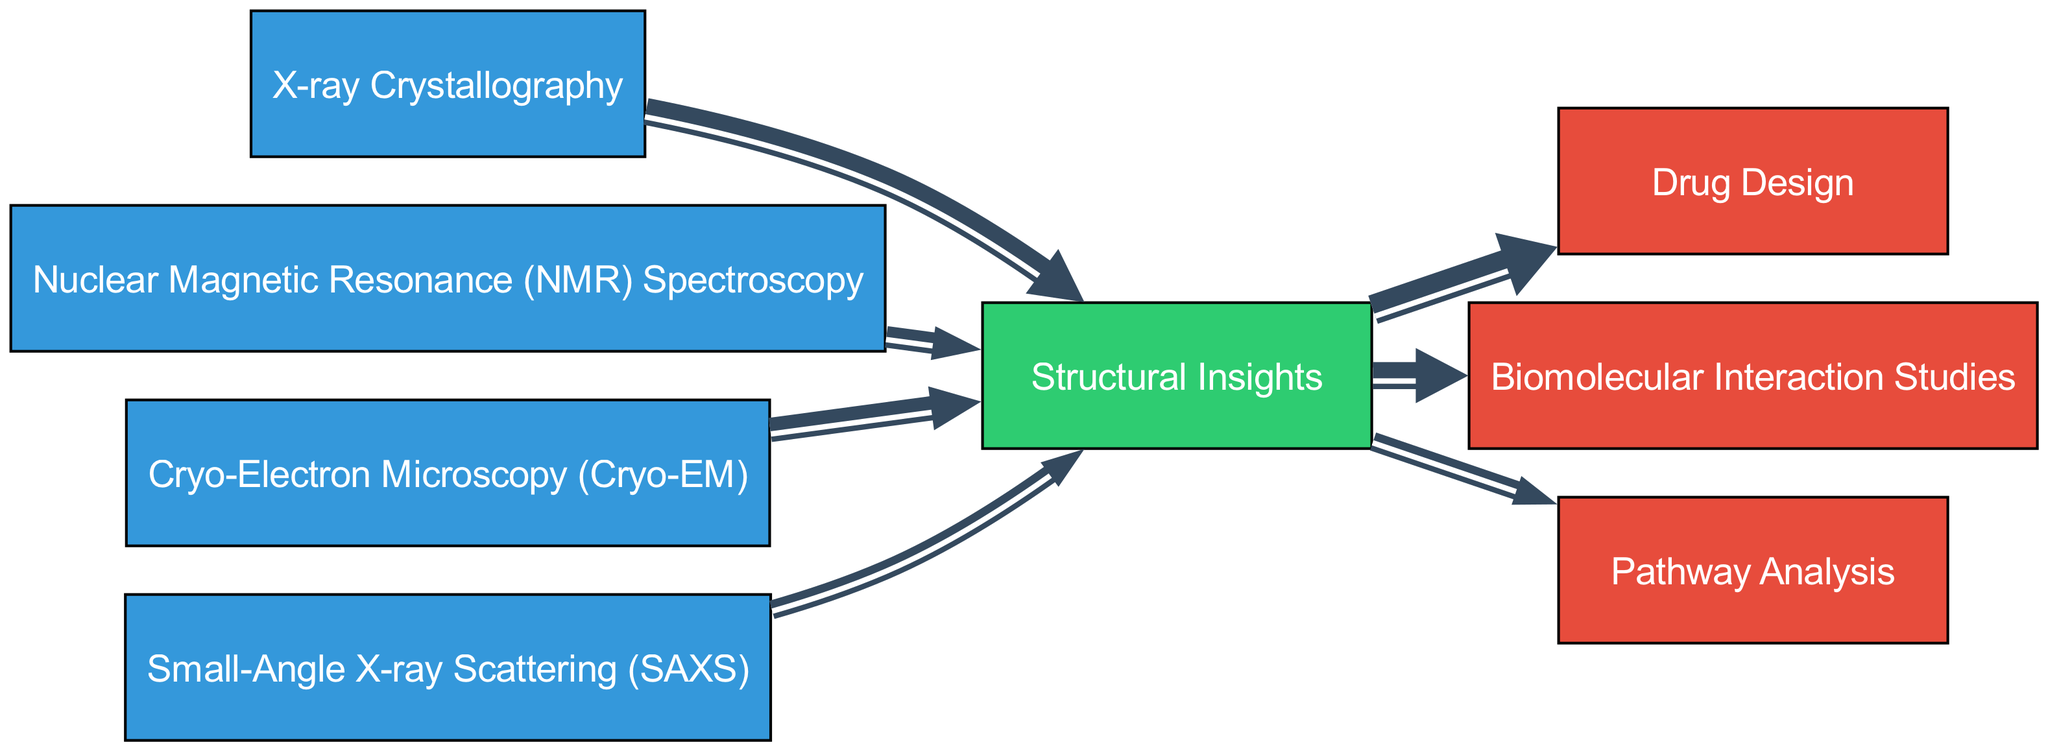What technique contributes the most to structural insights? By examining the links originating from the nodes representing techniques, I can see that X-ray Crystallography has the largest value of 30, indicating it contributes the most to Structural Insights.
Answer: X-ray Crystallography How many nodes are there in total? Counting the nodes listed in the data, there are eight distinct nodes representing techniques, outcomes, and research applications combined.
Answer: 8 What is the contribution value of Cryo-Electron Microscopy to structural insights? The value associated with Cryo-Electron Microscopy is 25, as indicated by the directed link leading to Structural Insights.
Answer: 25 Which research application has the highest value linked to structural insights? By reviewing the links from the Structural Insights node, I find that Drug Design has the highest value of 35.
Answer: Drug Design What is the total contribution value from all techniques to structural insights? To find this total, I sum the values from all links to Structural Insights: 30 (X-ray Crystallography) + 20 (NMR) + 25 (Cryo-EM) + 15 (SAXS) which equals 90.
Answer: 90 How do the techniques affect the pathway analysis application? Looking at the flow from Structural Insights to Pathway Analysis, the value is 15, indicating how much is contributed from techniques to this specific research application.
Answer: 15 Which technique and outcome connection has the least contribution value? By comparing the contributions to Structural Insights, Small-Angle X-ray Scattering (SAXS) contributes the least with a value of 15 before linking to structural insights.
Answer: Small-Angle X-ray Scattering What is the total flow value from structural insights to research applications? To find the total flow value, I sum the values leading to research applications: 35 (Drug Design) + 30 (Biomolecular Interaction Studies) + 15 (Pathway Analysis), equaling 80.
Answer: 80 